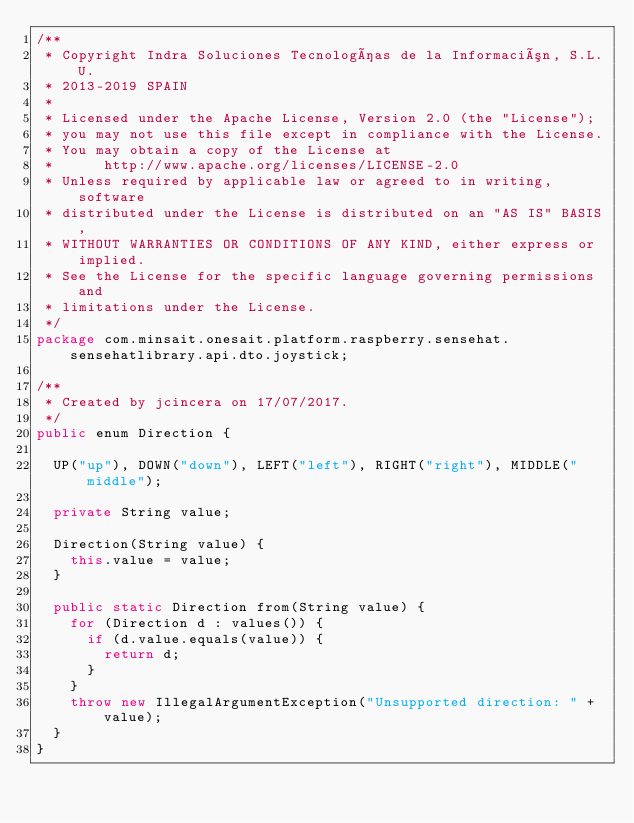Convert code to text. <code><loc_0><loc_0><loc_500><loc_500><_Java_>/**
 * Copyright Indra Soluciones Tecnologías de la Información, S.L.U.
 * 2013-2019 SPAIN
 *
 * Licensed under the Apache License, Version 2.0 (the "License");
 * you may not use this file except in compliance with the License.
 * You may obtain a copy of the License at
 *      http://www.apache.org/licenses/LICENSE-2.0
 * Unless required by applicable law or agreed to in writing, software
 * distributed under the License is distributed on an "AS IS" BASIS,
 * WITHOUT WARRANTIES OR CONDITIONS OF ANY KIND, either express or implied.
 * See the License for the specific language governing permissions and
 * limitations under the License.
 */
package com.minsait.onesait.platform.raspberry.sensehat.sensehatlibrary.api.dto.joystick;

/**
 * Created by jcincera on 17/07/2017.
 */
public enum Direction {

	UP("up"), DOWN("down"), LEFT("left"), RIGHT("right"), MIDDLE("middle");

	private String value;

	Direction(String value) {
		this.value = value;
	}

	public static Direction from(String value) {
		for (Direction d : values()) {
			if (d.value.equals(value)) {
				return d;
			}
		}
		throw new IllegalArgumentException("Unsupported direction: " + value);
	}
}
</code> 